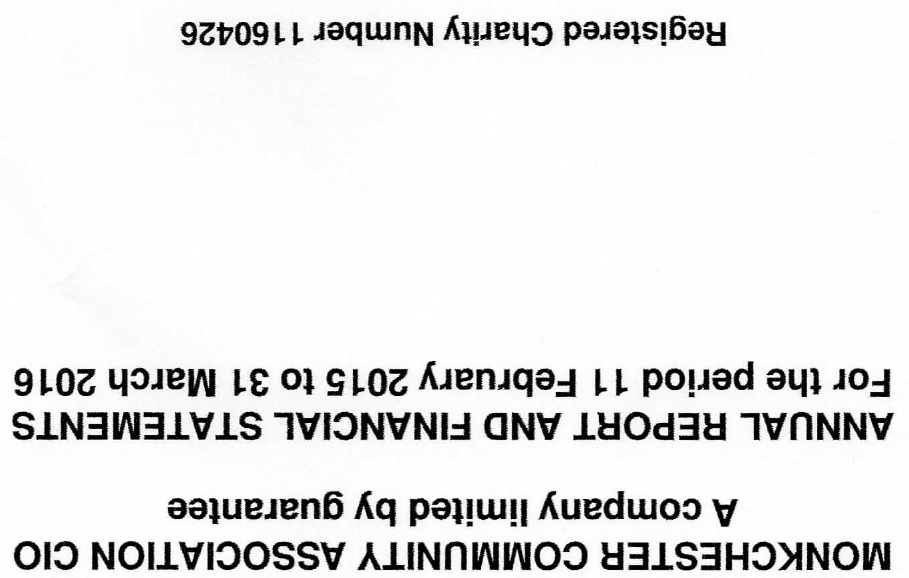What is the value for the income_annually_in_british_pounds?
Answer the question using a single word or phrase. None 